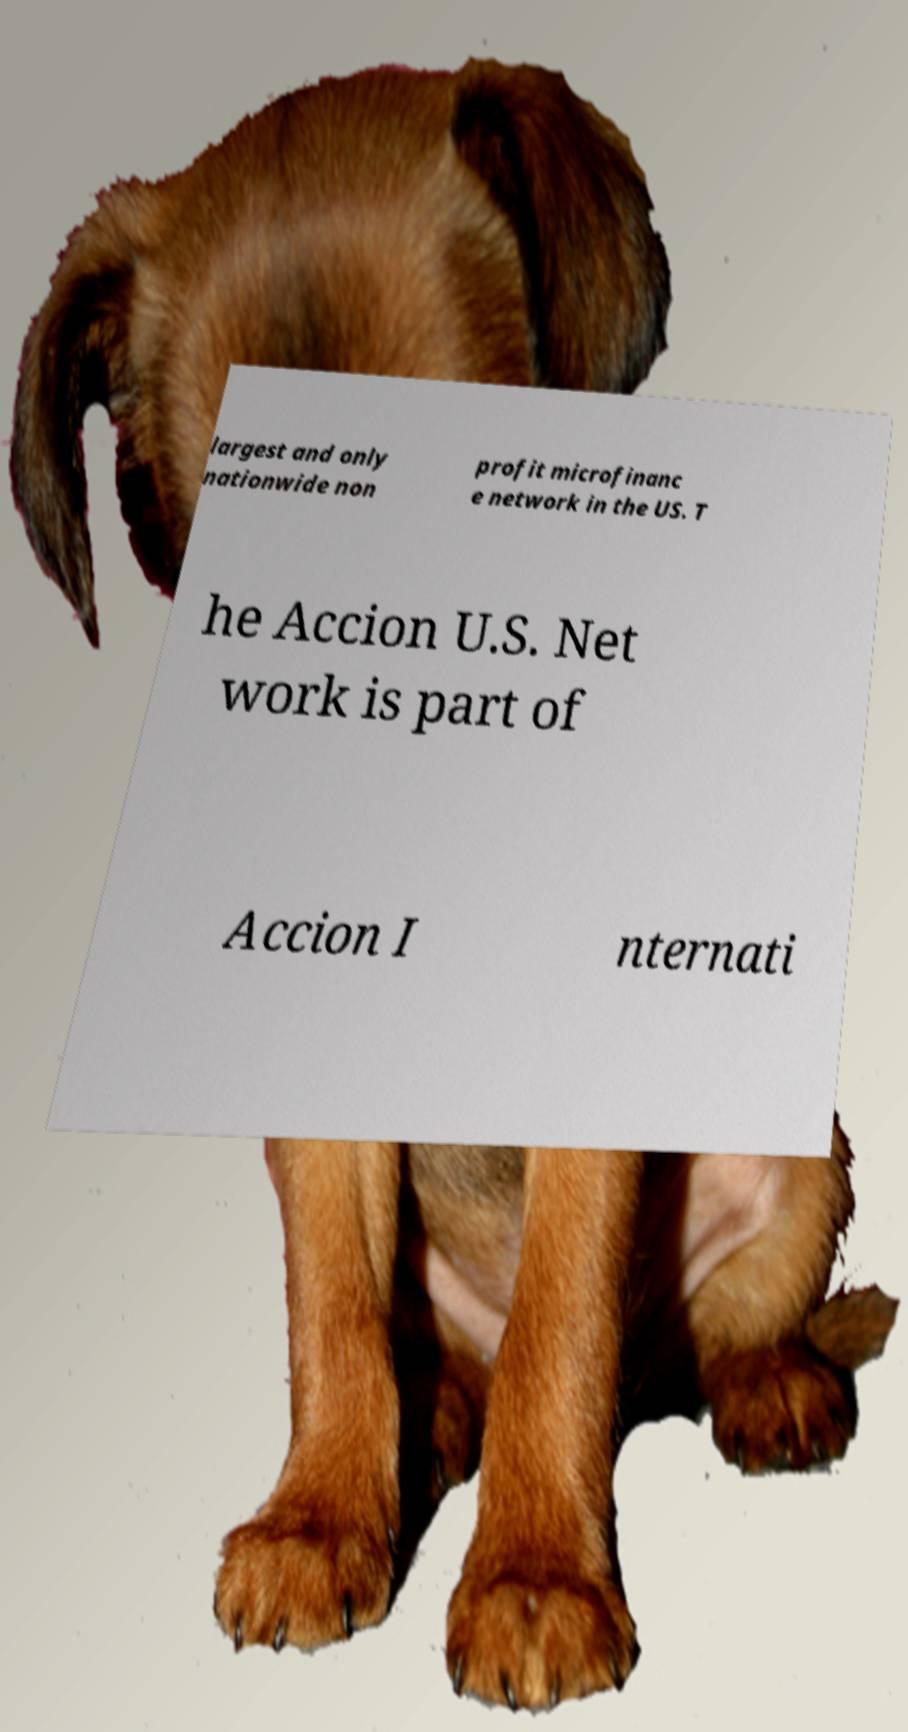Can you read and provide the text displayed in the image?This photo seems to have some interesting text. Can you extract and type it out for me? largest and only nationwide non profit microfinanc e network in the US. T he Accion U.S. Net work is part of Accion I nternati 